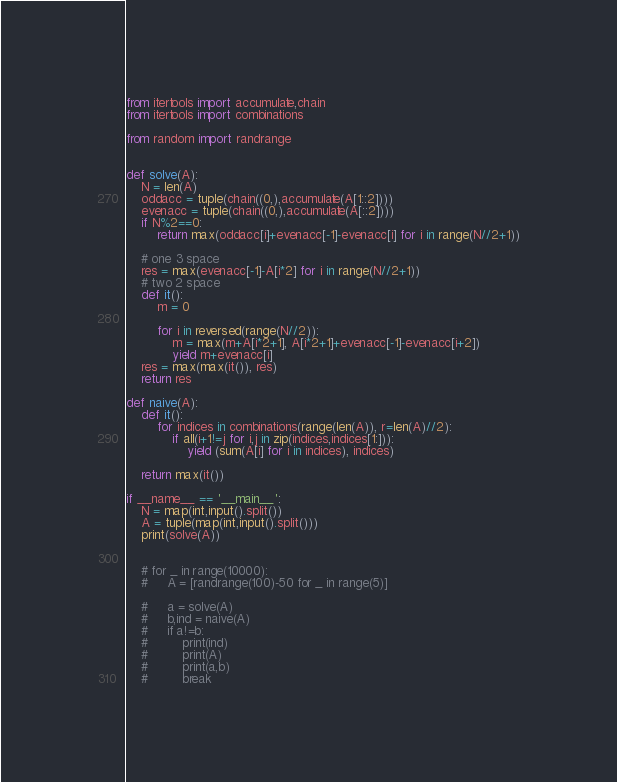<code> <loc_0><loc_0><loc_500><loc_500><_Python_>from itertools import accumulate,chain
from itertools import combinations

from random import randrange


def solve(A):
    N = len(A)
    oddacc = tuple(chain((0,),accumulate(A[1::2])))
    evenacc = tuple(chain((0,),accumulate(A[::2])))
    if N%2==0:
        return max(oddacc[i]+evenacc[-1]-evenacc[i] for i in range(N//2+1))

    # one 3 space
    res = max(evenacc[-1]-A[i*2] for i in range(N//2+1))
    # two 2 space
    def it():
        m = 0

        for i in reversed(range(N//2)):
            m = max(m+A[i*2+1], A[i*2+1]+evenacc[-1]-evenacc[i+2])
            yield m+evenacc[i]
    res = max(max(it()), res)
    return res

def naive(A):
    def it():
        for indices in combinations(range(len(A)), r=len(A)//2):
            if all(i+1!=j for i,j in zip(indices,indices[1:])):
                yield (sum(A[i] for i in indices), indices)

    return max(it())

if __name__ == '__main__':
    N = map(int,input().split())
    A = tuple(map(int,input().split()))
    print(solve(A))


    # for _ in range(10000):
    #     A = [randrange(100)-50 for _ in range(5)]

    #     a = solve(A)
    #     b,ind = naive(A)
    #     if a!=b:
    #         print(ind)
    #         print(A)
    #         print(a,b)
    #         break</code> 